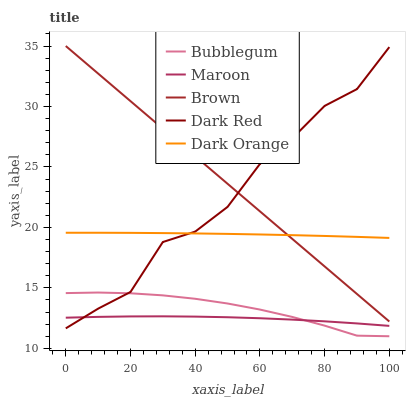Does Maroon have the minimum area under the curve?
Answer yes or no. Yes. Does Brown have the maximum area under the curve?
Answer yes or no. Yes. Does Brown have the minimum area under the curve?
Answer yes or no. No. Does Maroon have the maximum area under the curve?
Answer yes or no. No. Is Brown the smoothest?
Answer yes or no. Yes. Is Dark Red the roughest?
Answer yes or no. Yes. Is Maroon the smoothest?
Answer yes or no. No. Is Maroon the roughest?
Answer yes or no. No. Does Bubblegum have the lowest value?
Answer yes or no. Yes. Does Brown have the lowest value?
Answer yes or no. No. Does Brown have the highest value?
Answer yes or no. Yes. Does Maroon have the highest value?
Answer yes or no. No. Is Bubblegum less than Brown?
Answer yes or no. Yes. Is Brown greater than Maroon?
Answer yes or no. Yes. Does Brown intersect Dark Red?
Answer yes or no. Yes. Is Brown less than Dark Red?
Answer yes or no. No. Is Brown greater than Dark Red?
Answer yes or no. No. Does Bubblegum intersect Brown?
Answer yes or no. No. 